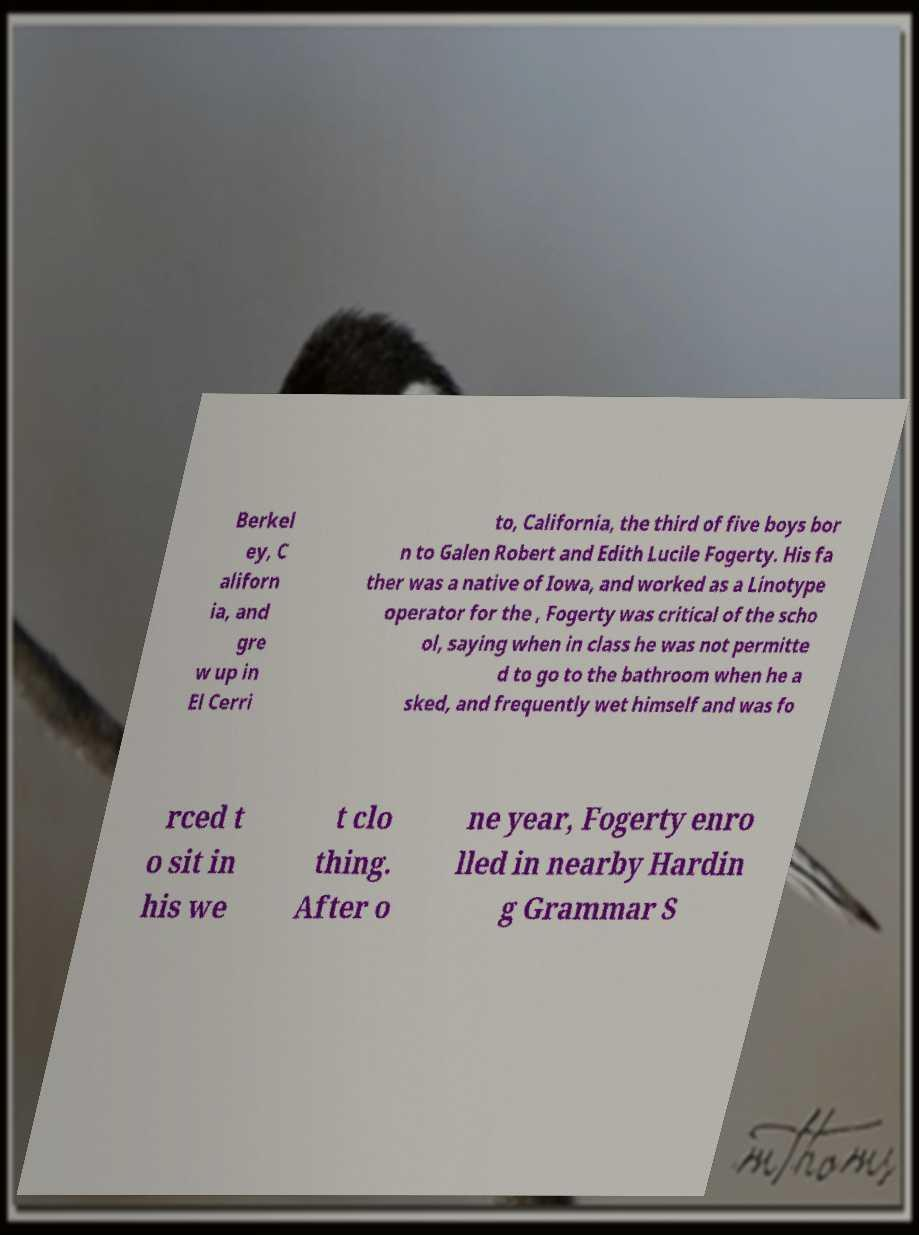I need the written content from this picture converted into text. Can you do that? Berkel ey, C aliforn ia, and gre w up in El Cerri to, California, the third of five boys bor n to Galen Robert and Edith Lucile Fogerty. His fa ther was a native of Iowa, and worked as a Linotype operator for the , Fogerty was critical of the scho ol, saying when in class he was not permitte d to go to the bathroom when he a sked, and frequently wet himself and was fo rced t o sit in his we t clo thing. After o ne year, Fogerty enro lled in nearby Hardin g Grammar S 